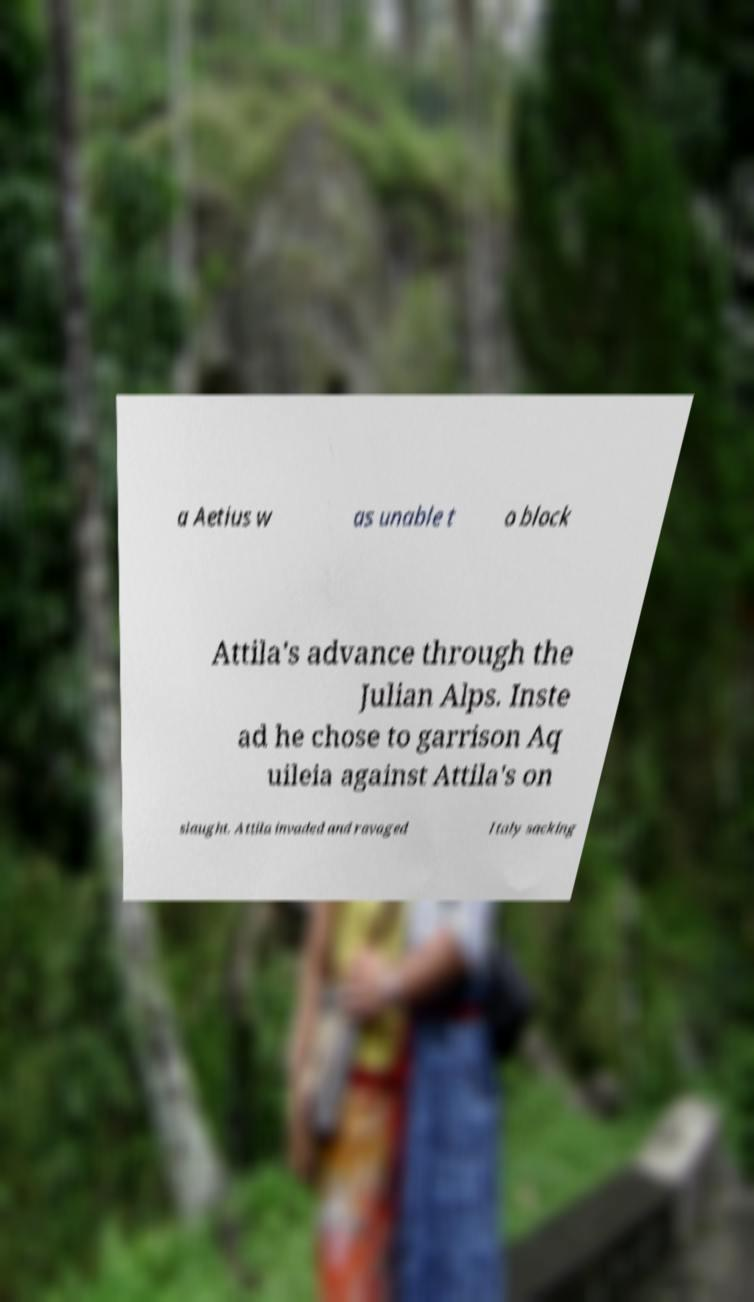Could you assist in decoding the text presented in this image and type it out clearly? a Aetius w as unable t o block Attila's advance through the Julian Alps. Inste ad he chose to garrison Aq uileia against Attila's on slaught. Attila invaded and ravaged Italy sacking 